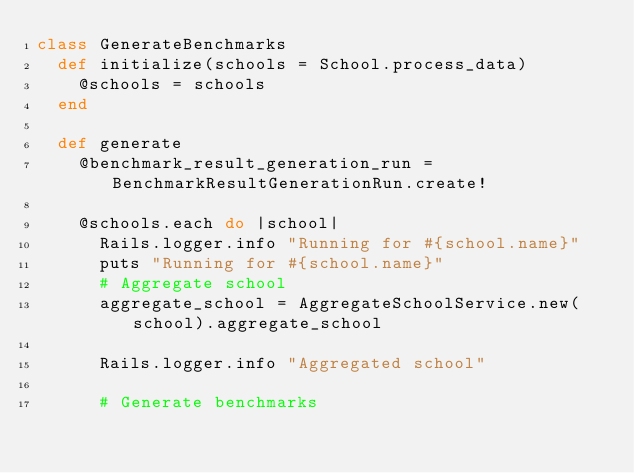<code> <loc_0><loc_0><loc_500><loc_500><_Ruby_>class GenerateBenchmarks
  def initialize(schools = School.process_data)
    @schools = schools
  end

  def generate
    @benchmark_result_generation_run = BenchmarkResultGenerationRun.create!

    @schools.each do |school|
      Rails.logger.info "Running for #{school.name}"
      puts "Running for #{school.name}"
      # Aggregate school
      aggregate_school = AggregateSchoolService.new(school).aggregate_school

      Rails.logger.info "Aggregated school"

      # Generate benchmarks</code> 